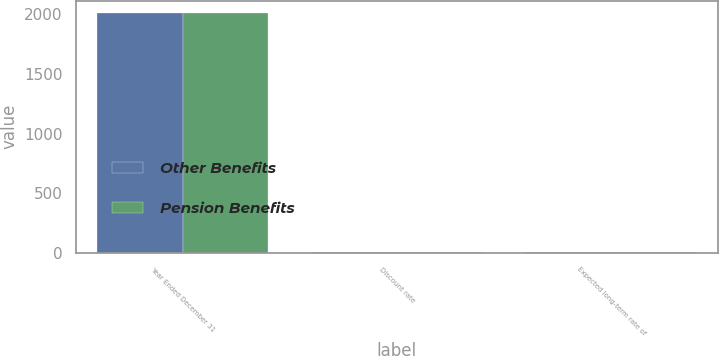<chart> <loc_0><loc_0><loc_500><loc_500><stacked_bar_chart><ecel><fcel>Year Ended December 31<fcel>Discount rate<fcel>Expected long-term rate of<nl><fcel>Other Benefits<fcel>2015<fcel>3.75<fcel>8.25<nl><fcel>Pension Benefits<fcel>2015<fcel>3.75<fcel>4.75<nl></chart> 